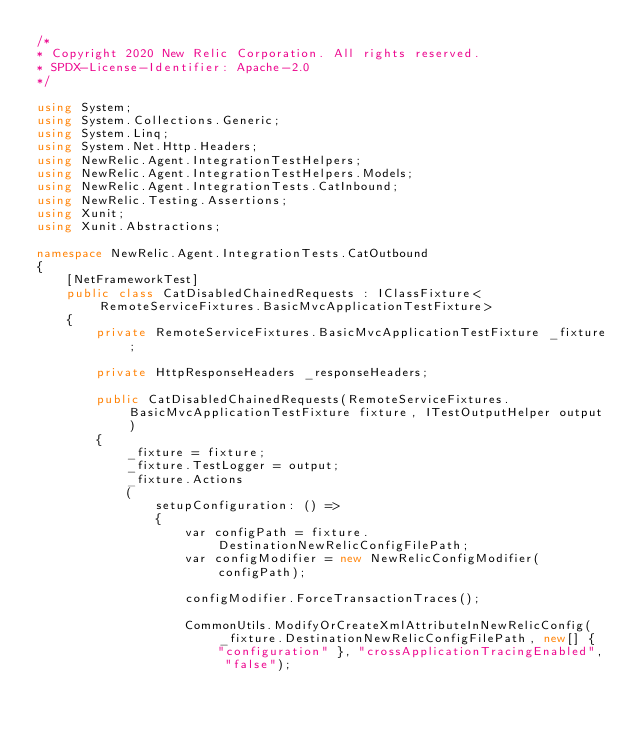<code> <loc_0><loc_0><loc_500><loc_500><_C#_>/*
* Copyright 2020 New Relic Corporation. All rights reserved.
* SPDX-License-Identifier: Apache-2.0
*/

using System;
using System.Collections.Generic;
using System.Linq;
using System.Net.Http.Headers;
using NewRelic.Agent.IntegrationTestHelpers;
using NewRelic.Agent.IntegrationTestHelpers.Models;
using NewRelic.Agent.IntegrationTests.CatInbound;
using NewRelic.Testing.Assertions;
using Xunit;
using Xunit.Abstractions;

namespace NewRelic.Agent.IntegrationTests.CatOutbound
{
    [NetFrameworkTest]
    public class CatDisabledChainedRequests : IClassFixture<RemoteServiceFixtures.BasicMvcApplicationTestFixture>
    {
        private RemoteServiceFixtures.BasicMvcApplicationTestFixture _fixture;

        private HttpResponseHeaders _responseHeaders;

        public CatDisabledChainedRequests(RemoteServiceFixtures.BasicMvcApplicationTestFixture fixture, ITestOutputHelper output)
        {
            _fixture = fixture;
            _fixture.TestLogger = output;
            _fixture.Actions
            (
                setupConfiguration: () =>
                {
                    var configPath = fixture.DestinationNewRelicConfigFilePath;
                    var configModifier = new NewRelicConfigModifier(configPath);

                    configModifier.ForceTransactionTraces();

                    CommonUtils.ModifyOrCreateXmlAttributeInNewRelicConfig(_fixture.DestinationNewRelicConfigFilePath, new[] { "configuration" }, "crossApplicationTracingEnabled", "false");</code> 